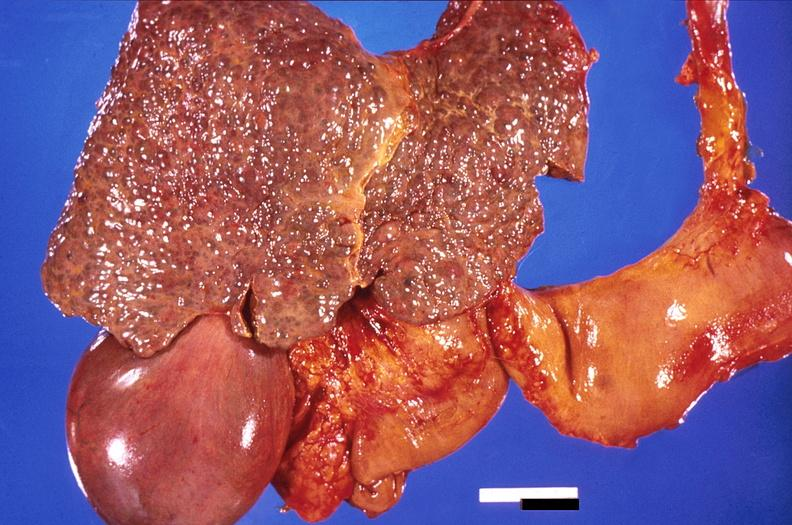does this image show liver, cirrhosis and enlarged gall bladder?
Answer the question using a single word or phrase. Yes 